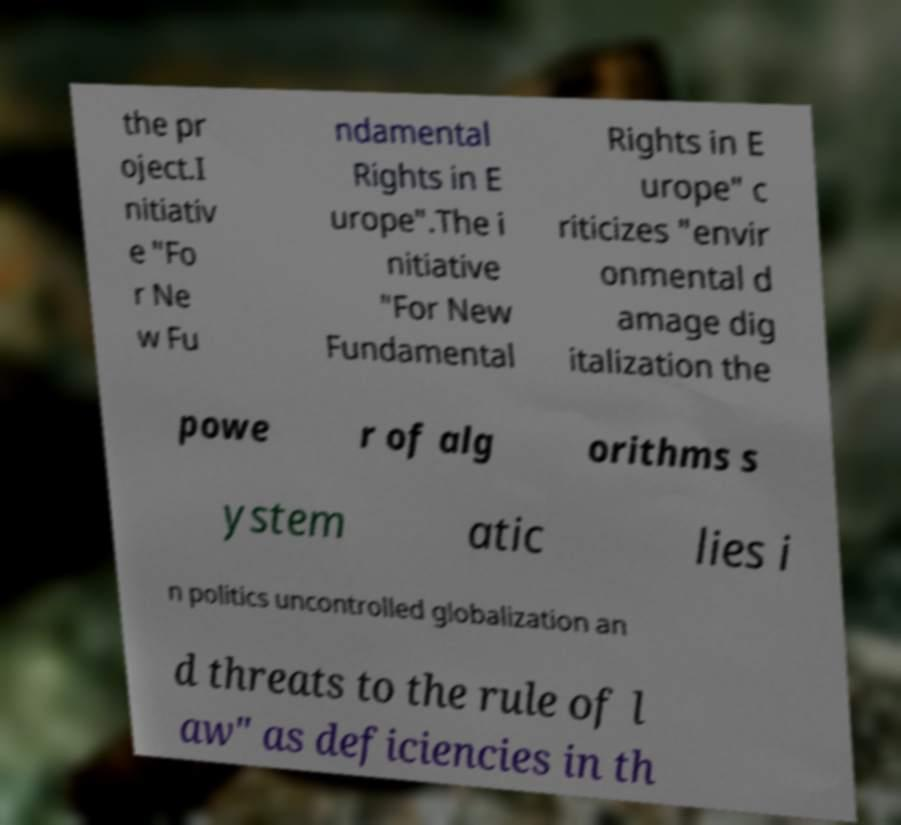Can you accurately transcribe the text from the provided image for me? the pr oject.I nitiativ e ″Fo r Ne w Fu ndamental Rights in E urope″.The i nitiative ″For New Fundamental Rights in E urope″ c riticizes "envir onmental d amage dig italization the powe r of alg orithms s ystem atic lies i n politics uncontrolled globalization an d threats to the rule of l aw" as deficiencies in th 